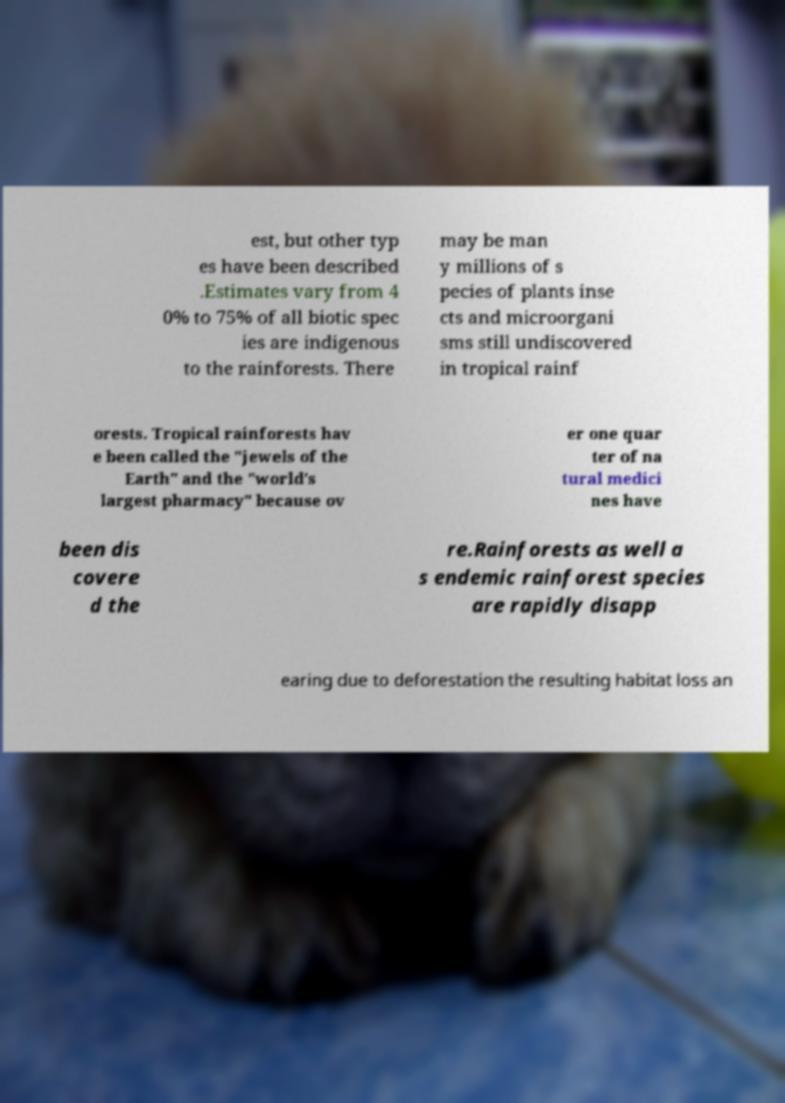What messages or text are displayed in this image? I need them in a readable, typed format. est, but other typ es have been described .Estimates vary from 4 0% to 75% of all biotic spec ies are indigenous to the rainforests. There may be man y millions of s pecies of plants inse cts and microorgani sms still undiscovered in tropical rainf orests. Tropical rainforests hav e been called the "jewels of the Earth" and the "world's largest pharmacy" because ov er one quar ter of na tural medici nes have been dis covere d the re.Rainforests as well a s endemic rainforest species are rapidly disapp earing due to deforestation the resulting habitat loss an 